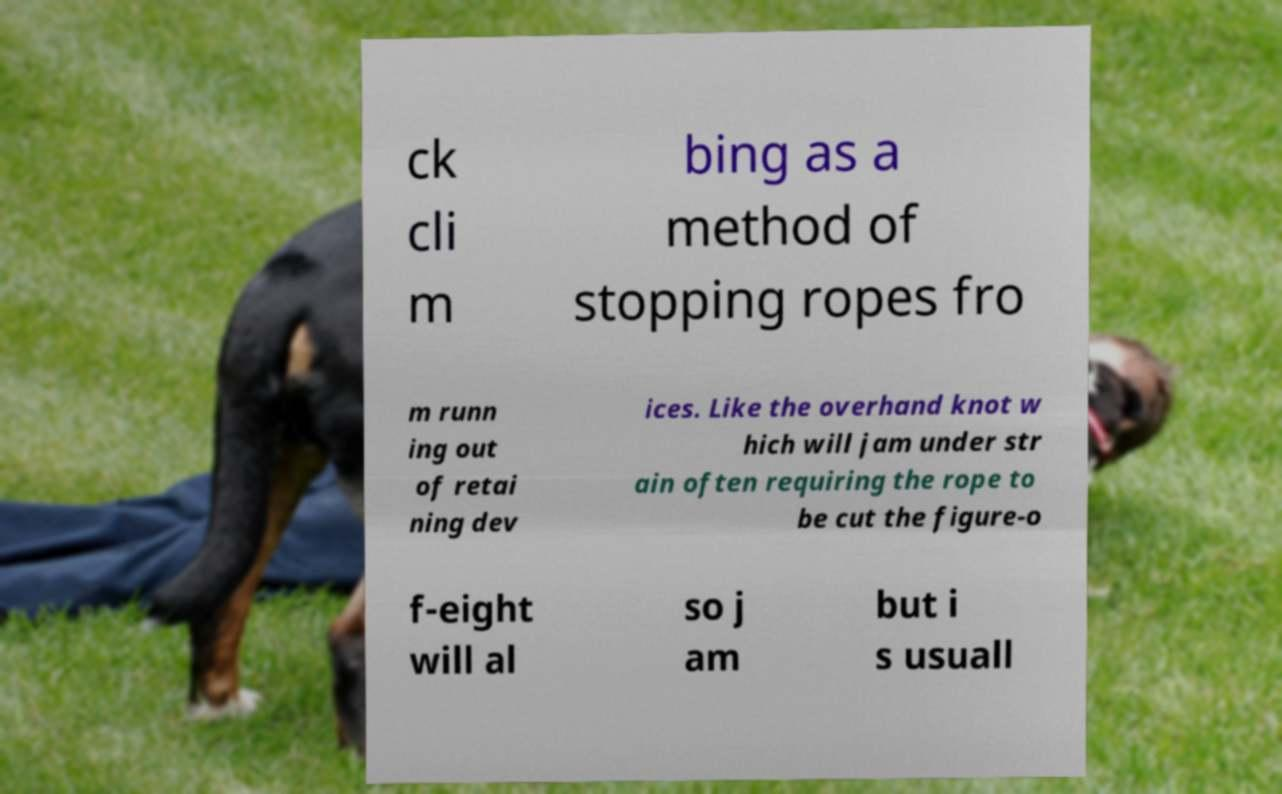For documentation purposes, I need the text within this image transcribed. Could you provide that? ck cli m bing as a method of stopping ropes fro m runn ing out of retai ning dev ices. Like the overhand knot w hich will jam under str ain often requiring the rope to be cut the figure-o f-eight will al so j am but i s usuall 